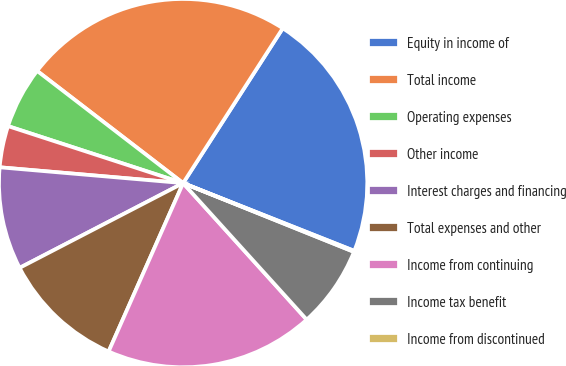Convert chart to OTSL. <chart><loc_0><loc_0><loc_500><loc_500><pie_chart><fcel>Equity in income of<fcel>Total income<fcel>Operating expenses<fcel>Other income<fcel>Interest charges and financing<fcel>Total expenses and other<fcel>Income from continuing<fcel>Income tax benefit<fcel>Income from discontinued<nl><fcel>21.9%<fcel>23.67%<fcel>5.42%<fcel>3.64%<fcel>8.98%<fcel>10.76%<fcel>18.34%<fcel>7.2%<fcel>0.09%<nl></chart> 